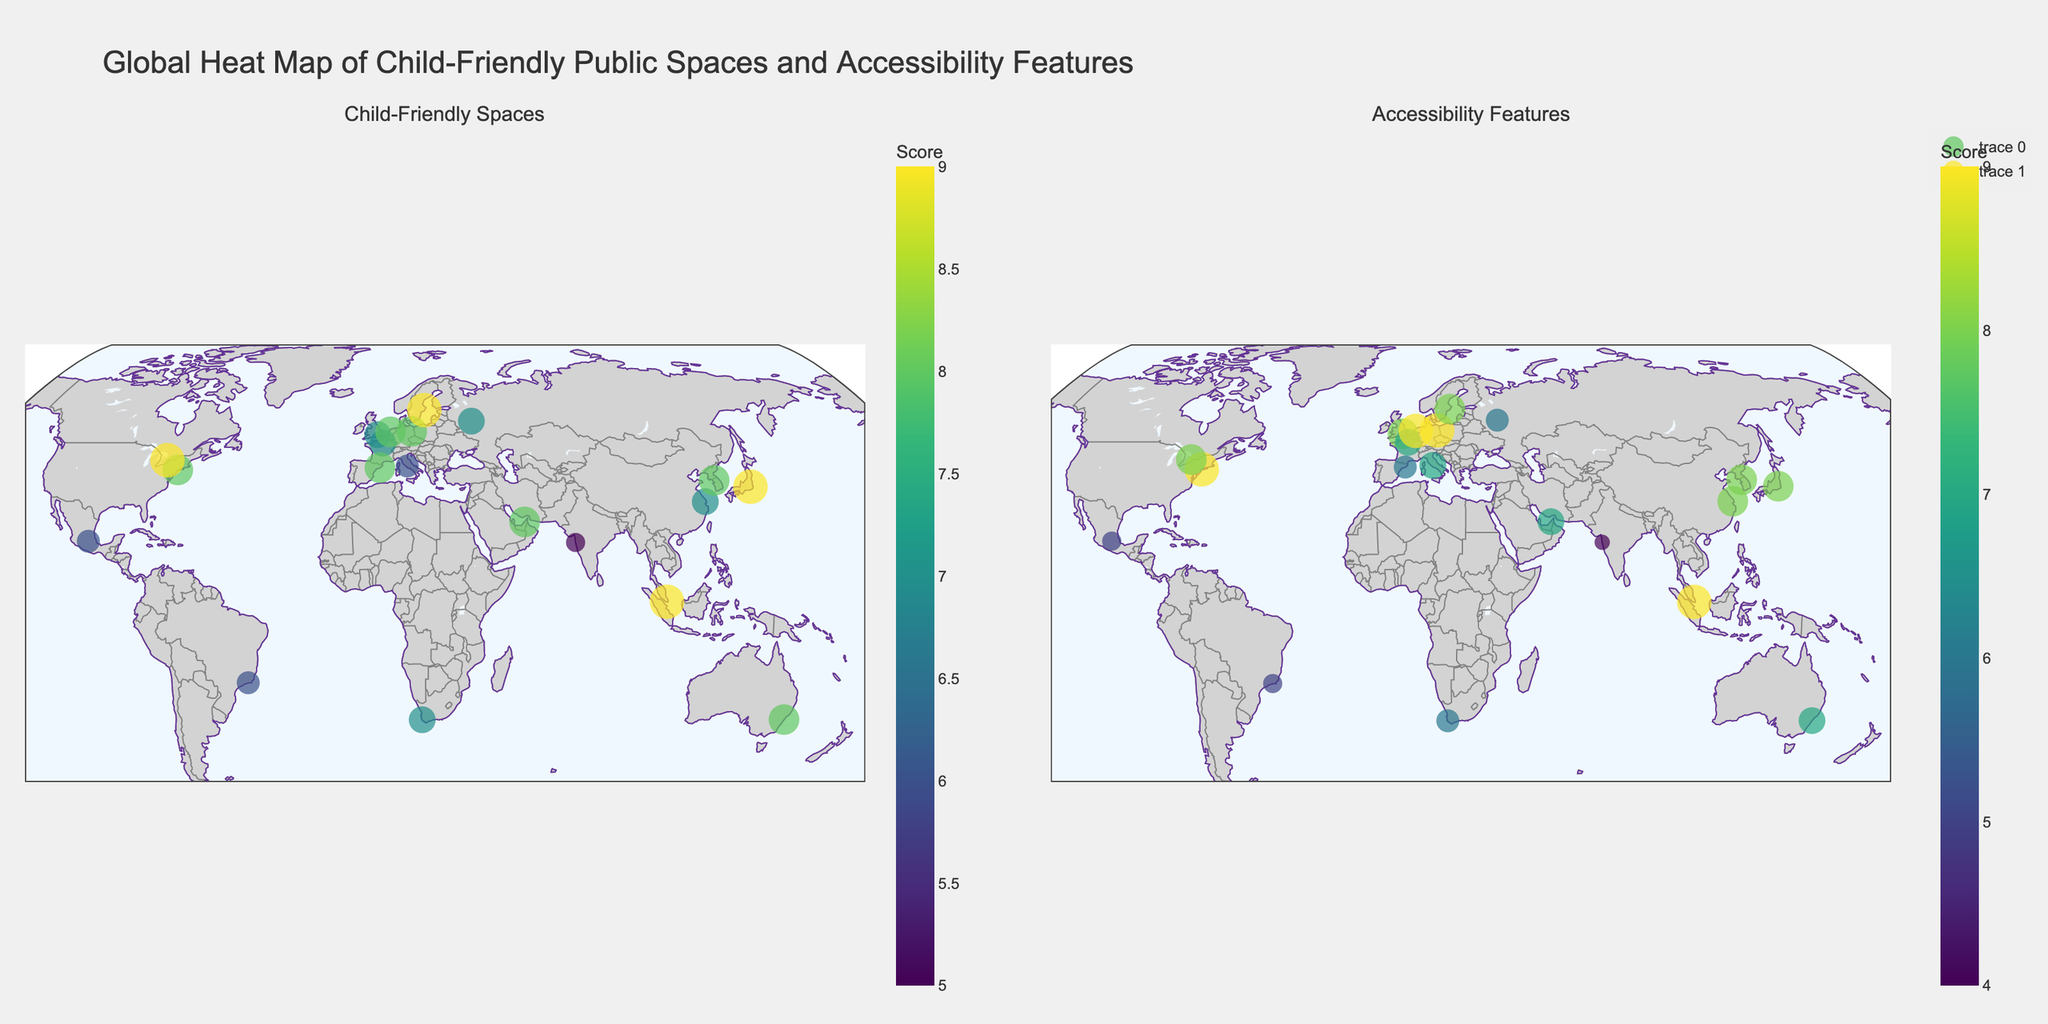What is the overall title of the figure? The overall title is located at the top center of the figure. It is meant to give an overarching description of what the entire plot represents.
Answer: Global Heat Map of Child-Friendly Public Spaces and Accessibility Features Which city has the highest score for child-friendly spaces? Locate the scattergeo plot for Child-Friendly Spaces and check the highest marker value. The city with the highest marker value for Child-Friendly Spaces is Tokyo with a score of 9.
Answer: Tokyo Which country has the highest score for accessibility features, and what is that score? On the Accessibility Features side of the plot, the marker signifies score values. The country with the highest score value and matching city label is Singapore with a score of 9.
Answer: Singapore, 9 What is the average score of child-friendly spaces across all the cities? Sum the Child-Friendly Spaces Scores of all cities, and then divide by the number of cities: (8+9+7+8+9+8+7+8+9+9+6+7+5+7+8+6+8+6+7+8)/20 = 7.55
Answer: 7.55 Compare the child-friendly space scores of New York and Tokyo. Which is higher? Compare the Child-Friendly Spaces Scores for New York (8) and Tokyo (9). Tokyo has the higher score.
Answer: Tokyo How many cities have the same score (9) for both child-friendly spaces and accessibility features? Evaluate both scattergeo plots. Look for cities where both scores are 9. Singapore and Berlin both have scores of 9 in both categories.
Answer: 2 Which city has the lowest score in accessbility features and what is the score? Scroll through the Accessibility Features plot and locate the smallest marker. The city with the smallest marker is Mumbai with a score of 4.
Answer: Mumbai, 4 Between Rome and Mexico City, which city has higher scores for accessibility features? Compare the Accessibility Features Scores: Rome has 7, and Mexico City has 5. Therefore, Rome has higher scores.
Answer: Rome What can you infer about the global distribution of child-friendly spaces and accessibility features in this dataset? Reviewing both scattergeo plots, it's observable that higher scores are mostly in developed countries like Tokyo, New York, and Singapore. Lower scores are more often in developing locations, such as Mumbai.
Answer: Higher scores in developed countries, lower in developing countries Which city has an equal score for both child-friendly spaces and accessibility features, and what is that score? Identify cities where both the Child-Friendly Spaces Score and the Accessibility Features Score are the same. Berlin has equal scores of 8 for both categories.
Answer: Berlin, 8 